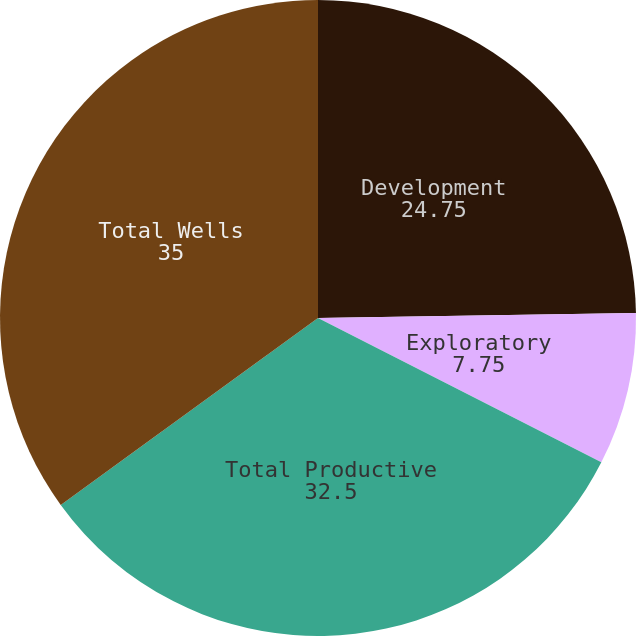Convert chart to OTSL. <chart><loc_0><loc_0><loc_500><loc_500><pie_chart><fcel>Development<fcel>Exploratory<fcel>Total Productive<fcel>Total Wells<nl><fcel>24.75%<fcel>7.75%<fcel>32.5%<fcel>35.0%<nl></chart> 